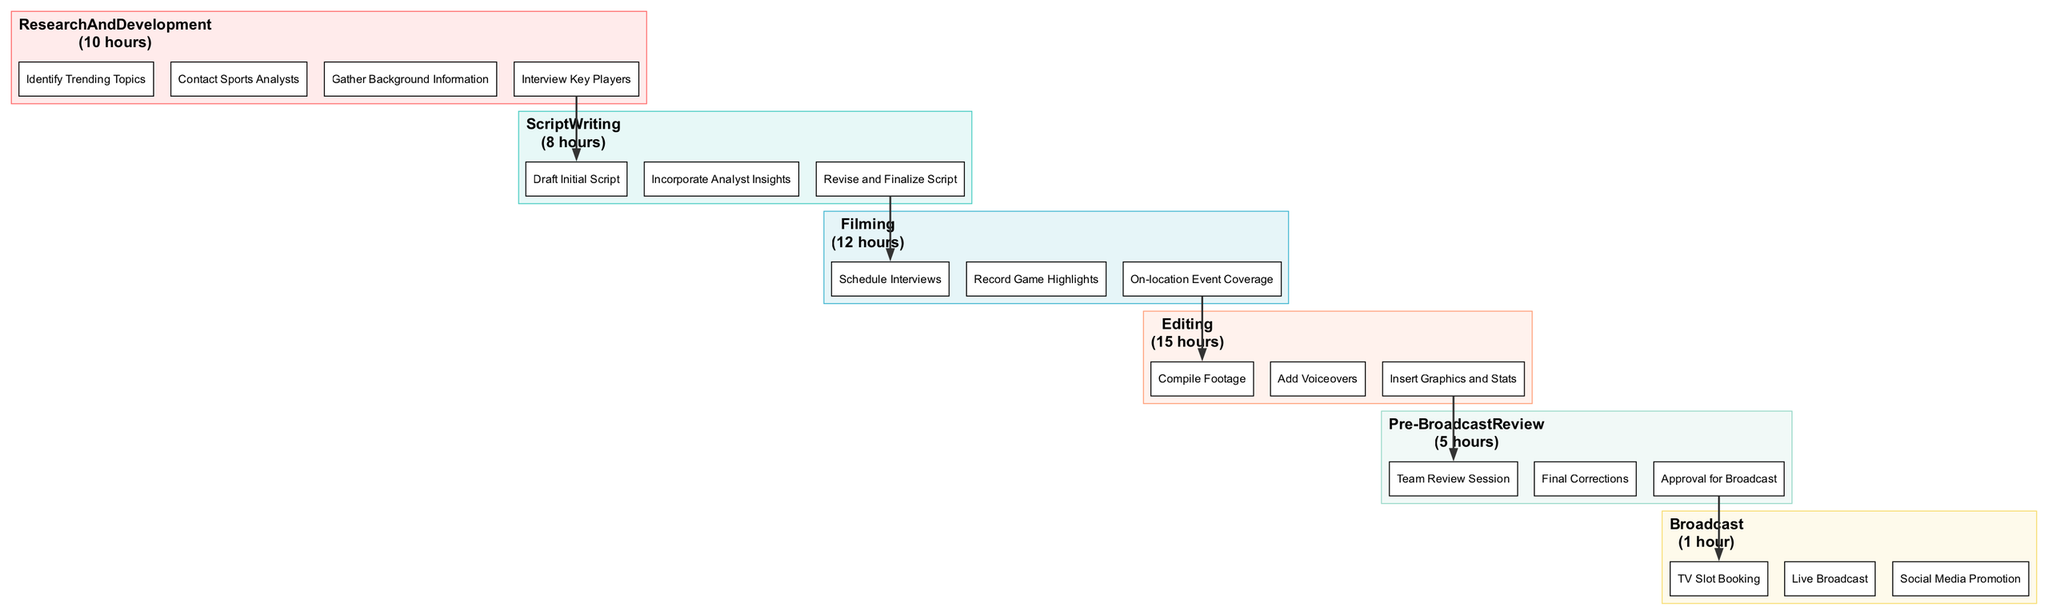What is the time allocation for Script Writing? The block for Script Writing indicates the time allocated as "8 hours". This is directly taken from the label of the Script Writing phase in the block diagram.
Answer: 8 hours Which phase has the highest time allocation? The Editing phase shows a time allocation of "15 hours", which is the highest when compared to other phases' time allocations. This comparison involves reviewing each phase's time allocation to identify the maximum.
Answer: 15 hours What is the last milestone in the Filming phase? The last milestone listed under the Filming phase is "On-location Event Coverage". This is identified by looking at the order of milestones presented in the Filming block.
Answer: On-location Event Coverage How many total phases are there in the schedule? There are six distinct phases listed in the diagram: Research And Development, Script Writing, Filming, Editing, Pre-Broadcast Review, and Broadcast. A simple count of the phase blocks confirms the total.
Answer: 6 Which phase comes directly before the Editing phase? The phase that comes directly before Editing is the Filming phase. This is determined by following the flow of the diagram from Research And Development to Broadcast.
Answer: Filming What is the time allocation for the Pre-Broadcast Review phase? The label for the Pre-Broadcast Review phase shows a time allocation of "5 hours". This is read directly from the block corresponding to that phase.
Answer: 5 hours What milestone follows "Draft Initial Script"? The milestone that follows "Draft Initial Script" is "Incorporate Analyst Insights". In the Script Writing phase milestones, this is the next entry after the first.
Answer: Incorporate Analyst Insights How many total hours are allocated to Filming and Editing combined? The total hours allocated are "12 hours" for Filming and "15 hours" for Editing, which adds up to "27 hours". This is calculated by summing the time allocations of both phases together.
Answer: 27 hours What is the purpose of the final phase, Broadcast? The Broadcast phase includes milestones such as "Live Broadcast" and "Social Media Promotion". It signifies the culmination of the content production process with actions focused on airing the content.
Answer: Live Broadcast 